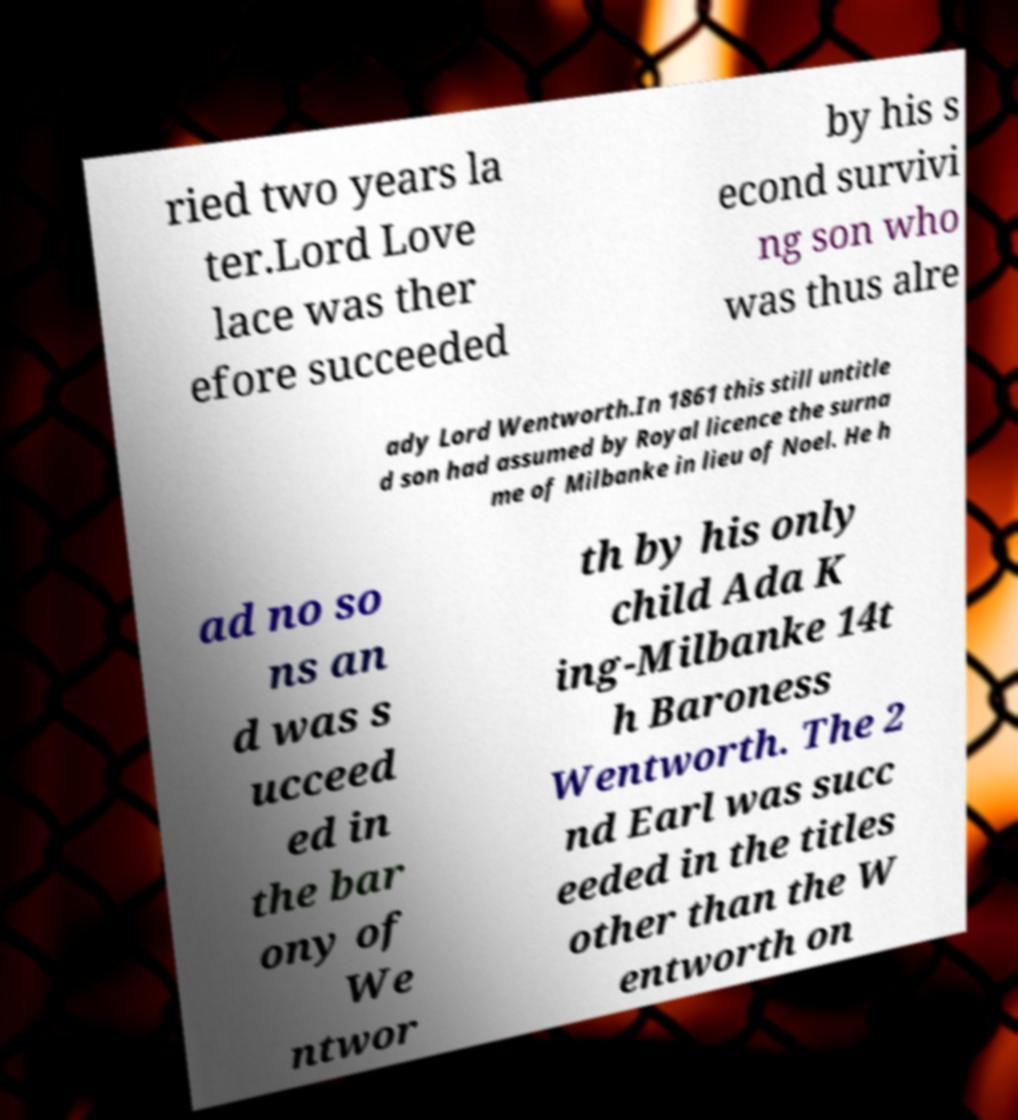There's text embedded in this image that I need extracted. Can you transcribe it verbatim? ried two years la ter.Lord Love lace was ther efore succeeded by his s econd survivi ng son who was thus alre ady Lord Wentworth.In 1861 this still untitle d son had assumed by Royal licence the surna me of Milbanke in lieu of Noel. He h ad no so ns an d was s ucceed ed in the bar ony of We ntwor th by his only child Ada K ing-Milbanke 14t h Baroness Wentworth. The 2 nd Earl was succ eeded in the titles other than the W entworth on 